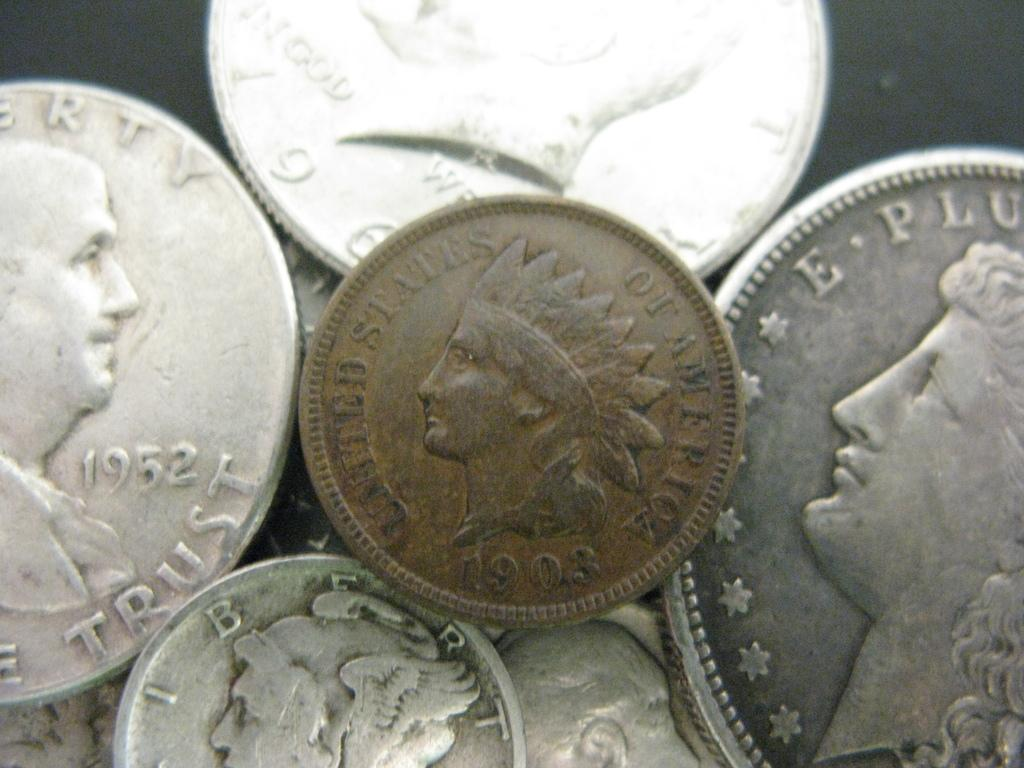<image>
Offer a succinct explanation of the picture presented. A 1903 coin features an Indian figure on it. 